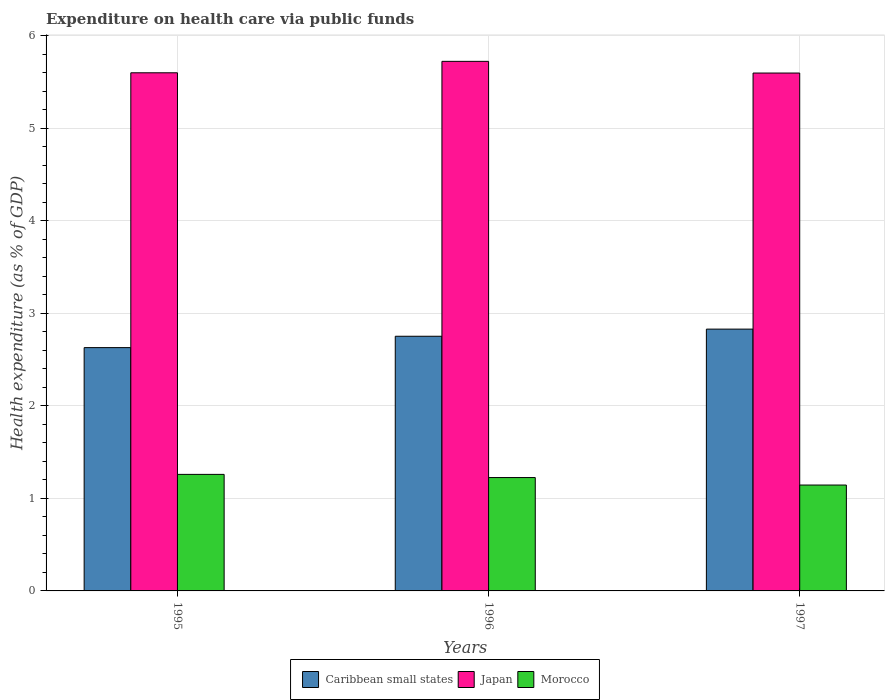How many different coloured bars are there?
Ensure brevity in your answer.  3. Are the number of bars on each tick of the X-axis equal?
Ensure brevity in your answer.  Yes. What is the expenditure made on health care in Morocco in 1996?
Your answer should be very brief. 1.23. Across all years, what is the maximum expenditure made on health care in Morocco?
Provide a succinct answer. 1.26. Across all years, what is the minimum expenditure made on health care in Japan?
Offer a very short reply. 5.6. In which year was the expenditure made on health care in Caribbean small states minimum?
Keep it short and to the point. 1995. What is the total expenditure made on health care in Morocco in the graph?
Offer a terse response. 3.63. What is the difference between the expenditure made on health care in Japan in 1996 and that in 1997?
Your response must be concise. 0.13. What is the difference between the expenditure made on health care in Japan in 1997 and the expenditure made on health care in Caribbean small states in 1995?
Your answer should be very brief. 2.97. What is the average expenditure made on health care in Japan per year?
Offer a very short reply. 5.64. In the year 1995, what is the difference between the expenditure made on health care in Japan and expenditure made on health care in Morocco?
Provide a succinct answer. 4.34. What is the ratio of the expenditure made on health care in Caribbean small states in 1995 to that in 1997?
Provide a short and direct response. 0.93. Is the expenditure made on health care in Japan in 1996 less than that in 1997?
Offer a terse response. No. Is the difference between the expenditure made on health care in Japan in 1995 and 1996 greater than the difference between the expenditure made on health care in Morocco in 1995 and 1996?
Give a very brief answer. No. What is the difference between the highest and the second highest expenditure made on health care in Japan?
Provide a succinct answer. 0.12. What is the difference between the highest and the lowest expenditure made on health care in Morocco?
Your answer should be very brief. 0.12. In how many years, is the expenditure made on health care in Caribbean small states greater than the average expenditure made on health care in Caribbean small states taken over all years?
Your answer should be very brief. 2. Is the sum of the expenditure made on health care in Morocco in 1996 and 1997 greater than the maximum expenditure made on health care in Japan across all years?
Make the answer very short. No. What does the 3rd bar from the right in 1997 represents?
Your answer should be compact. Caribbean small states. Is it the case that in every year, the sum of the expenditure made on health care in Japan and expenditure made on health care in Morocco is greater than the expenditure made on health care in Caribbean small states?
Keep it short and to the point. Yes. How many bars are there?
Make the answer very short. 9. How many years are there in the graph?
Your answer should be very brief. 3. What is the difference between two consecutive major ticks on the Y-axis?
Provide a succinct answer. 1. Does the graph contain any zero values?
Provide a short and direct response. No. How are the legend labels stacked?
Your answer should be very brief. Horizontal. What is the title of the graph?
Your answer should be compact. Expenditure on health care via public funds. Does "Northern Mariana Islands" appear as one of the legend labels in the graph?
Offer a terse response. No. What is the label or title of the X-axis?
Offer a very short reply. Years. What is the label or title of the Y-axis?
Your response must be concise. Health expenditure (as % of GDP). What is the Health expenditure (as % of GDP) in Caribbean small states in 1995?
Keep it short and to the point. 2.63. What is the Health expenditure (as % of GDP) of Japan in 1995?
Your response must be concise. 5.6. What is the Health expenditure (as % of GDP) in Morocco in 1995?
Make the answer very short. 1.26. What is the Health expenditure (as % of GDP) in Caribbean small states in 1996?
Your answer should be compact. 2.75. What is the Health expenditure (as % of GDP) in Japan in 1996?
Your response must be concise. 5.72. What is the Health expenditure (as % of GDP) of Morocco in 1996?
Your answer should be very brief. 1.23. What is the Health expenditure (as % of GDP) of Caribbean small states in 1997?
Your answer should be compact. 2.83. What is the Health expenditure (as % of GDP) of Japan in 1997?
Give a very brief answer. 5.6. What is the Health expenditure (as % of GDP) of Morocco in 1997?
Provide a short and direct response. 1.14. Across all years, what is the maximum Health expenditure (as % of GDP) in Caribbean small states?
Make the answer very short. 2.83. Across all years, what is the maximum Health expenditure (as % of GDP) of Japan?
Offer a terse response. 5.72. Across all years, what is the maximum Health expenditure (as % of GDP) of Morocco?
Offer a terse response. 1.26. Across all years, what is the minimum Health expenditure (as % of GDP) of Caribbean small states?
Your response must be concise. 2.63. Across all years, what is the minimum Health expenditure (as % of GDP) in Japan?
Your answer should be compact. 5.6. Across all years, what is the minimum Health expenditure (as % of GDP) of Morocco?
Offer a very short reply. 1.14. What is the total Health expenditure (as % of GDP) in Caribbean small states in the graph?
Provide a succinct answer. 8.21. What is the total Health expenditure (as % of GDP) in Japan in the graph?
Offer a terse response. 16.92. What is the total Health expenditure (as % of GDP) in Morocco in the graph?
Your answer should be very brief. 3.63. What is the difference between the Health expenditure (as % of GDP) in Caribbean small states in 1995 and that in 1996?
Offer a terse response. -0.12. What is the difference between the Health expenditure (as % of GDP) in Japan in 1995 and that in 1996?
Your answer should be compact. -0.12. What is the difference between the Health expenditure (as % of GDP) in Morocco in 1995 and that in 1996?
Offer a terse response. 0.03. What is the difference between the Health expenditure (as % of GDP) in Japan in 1995 and that in 1997?
Provide a short and direct response. 0. What is the difference between the Health expenditure (as % of GDP) in Morocco in 1995 and that in 1997?
Provide a succinct answer. 0.12. What is the difference between the Health expenditure (as % of GDP) in Caribbean small states in 1996 and that in 1997?
Make the answer very short. -0.08. What is the difference between the Health expenditure (as % of GDP) of Japan in 1996 and that in 1997?
Your response must be concise. 0.13. What is the difference between the Health expenditure (as % of GDP) in Morocco in 1996 and that in 1997?
Offer a terse response. 0.08. What is the difference between the Health expenditure (as % of GDP) in Caribbean small states in 1995 and the Health expenditure (as % of GDP) in Japan in 1996?
Ensure brevity in your answer.  -3.09. What is the difference between the Health expenditure (as % of GDP) of Caribbean small states in 1995 and the Health expenditure (as % of GDP) of Morocco in 1996?
Make the answer very short. 1.4. What is the difference between the Health expenditure (as % of GDP) of Japan in 1995 and the Health expenditure (as % of GDP) of Morocco in 1996?
Provide a short and direct response. 4.37. What is the difference between the Health expenditure (as % of GDP) in Caribbean small states in 1995 and the Health expenditure (as % of GDP) in Japan in 1997?
Offer a very short reply. -2.97. What is the difference between the Health expenditure (as % of GDP) of Caribbean small states in 1995 and the Health expenditure (as % of GDP) of Morocco in 1997?
Give a very brief answer. 1.49. What is the difference between the Health expenditure (as % of GDP) of Japan in 1995 and the Health expenditure (as % of GDP) of Morocco in 1997?
Offer a terse response. 4.46. What is the difference between the Health expenditure (as % of GDP) of Caribbean small states in 1996 and the Health expenditure (as % of GDP) of Japan in 1997?
Ensure brevity in your answer.  -2.84. What is the difference between the Health expenditure (as % of GDP) in Caribbean small states in 1996 and the Health expenditure (as % of GDP) in Morocco in 1997?
Provide a short and direct response. 1.61. What is the difference between the Health expenditure (as % of GDP) of Japan in 1996 and the Health expenditure (as % of GDP) of Morocco in 1997?
Ensure brevity in your answer.  4.58. What is the average Health expenditure (as % of GDP) in Caribbean small states per year?
Make the answer very short. 2.74. What is the average Health expenditure (as % of GDP) in Japan per year?
Provide a succinct answer. 5.64. What is the average Health expenditure (as % of GDP) in Morocco per year?
Offer a terse response. 1.21. In the year 1995, what is the difference between the Health expenditure (as % of GDP) of Caribbean small states and Health expenditure (as % of GDP) of Japan?
Give a very brief answer. -2.97. In the year 1995, what is the difference between the Health expenditure (as % of GDP) of Caribbean small states and Health expenditure (as % of GDP) of Morocco?
Keep it short and to the point. 1.37. In the year 1995, what is the difference between the Health expenditure (as % of GDP) in Japan and Health expenditure (as % of GDP) in Morocco?
Make the answer very short. 4.34. In the year 1996, what is the difference between the Health expenditure (as % of GDP) of Caribbean small states and Health expenditure (as % of GDP) of Japan?
Your answer should be very brief. -2.97. In the year 1996, what is the difference between the Health expenditure (as % of GDP) in Caribbean small states and Health expenditure (as % of GDP) in Morocco?
Offer a very short reply. 1.53. In the year 1996, what is the difference between the Health expenditure (as % of GDP) in Japan and Health expenditure (as % of GDP) in Morocco?
Keep it short and to the point. 4.5. In the year 1997, what is the difference between the Health expenditure (as % of GDP) in Caribbean small states and Health expenditure (as % of GDP) in Japan?
Your answer should be compact. -2.77. In the year 1997, what is the difference between the Health expenditure (as % of GDP) in Caribbean small states and Health expenditure (as % of GDP) in Morocco?
Offer a terse response. 1.69. In the year 1997, what is the difference between the Health expenditure (as % of GDP) of Japan and Health expenditure (as % of GDP) of Morocco?
Your response must be concise. 4.45. What is the ratio of the Health expenditure (as % of GDP) in Caribbean small states in 1995 to that in 1996?
Your answer should be compact. 0.96. What is the ratio of the Health expenditure (as % of GDP) in Japan in 1995 to that in 1996?
Make the answer very short. 0.98. What is the ratio of the Health expenditure (as % of GDP) in Morocco in 1995 to that in 1996?
Give a very brief answer. 1.03. What is the ratio of the Health expenditure (as % of GDP) of Caribbean small states in 1995 to that in 1997?
Offer a very short reply. 0.93. What is the ratio of the Health expenditure (as % of GDP) in Morocco in 1995 to that in 1997?
Keep it short and to the point. 1.1. What is the ratio of the Health expenditure (as % of GDP) in Caribbean small states in 1996 to that in 1997?
Provide a short and direct response. 0.97. What is the ratio of the Health expenditure (as % of GDP) of Japan in 1996 to that in 1997?
Your answer should be compact. 1.02. What is the ratio of the Health expenditure (as % of GDP) of Morocco in 1996 to that in 1997?
Give a very brief answer. 1.07. What is the difference between the highest and the second highest Health expenditure (as % of GDP) in Caribbean small states?
Your answer should be very brief. 0.08. What is the difference between the highest and the second highest Health expenditure (as % of GDP) in Japan?
Provide a succinct answer. 0.12. What is the difference between the highest and the second highest Health expenditure (as % of GDP) in Morocco?
Offer a terse response. 0.03. What is the difference between the highest and the lowest Health expenditure (as % of GDP) of Japan?
Your response must be concise. 0.13. What is the difference between the highest and the lowest Health expenditure (as % of GDP) in Morocco?
Your answer should be very brief. 0.12. 